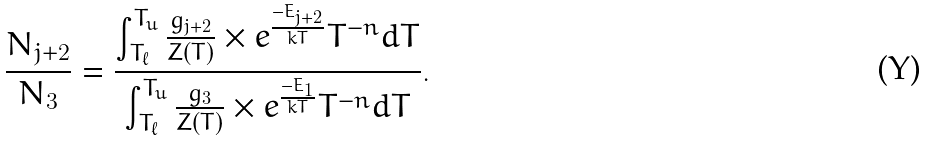Convert formula to latex. <formula><loc_0><loc_0><loc_500><loc_500>\frac { N _ { j + 2 } } { N _ { 3 } } = \frac { \int _ { T _ { \ell } } ^ { T _ { u } } \frac { g _ { j + 2 } } { Z ( T ) } \times e ^ { \frac { - E _ { j + 2 } } { k T } } T ^ { - n } d T } { \int _ { T _ { \ell } } ^ { T _ { u } } \frac { g _ { 3 } } { Z ( T ) } \times e ^ { \frac { - E _ { 1 } } { k T } } T ^ { - n } d T } .</formula> 